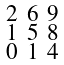<formula> <loc_0><loc_0><loc_500><loc_500>\begin{smallmatrix} 2 & 6 & 9 \\ 1 & 5 & 8 \\ 0 & 1 & 4 \end{smallmatrix}</formula> 